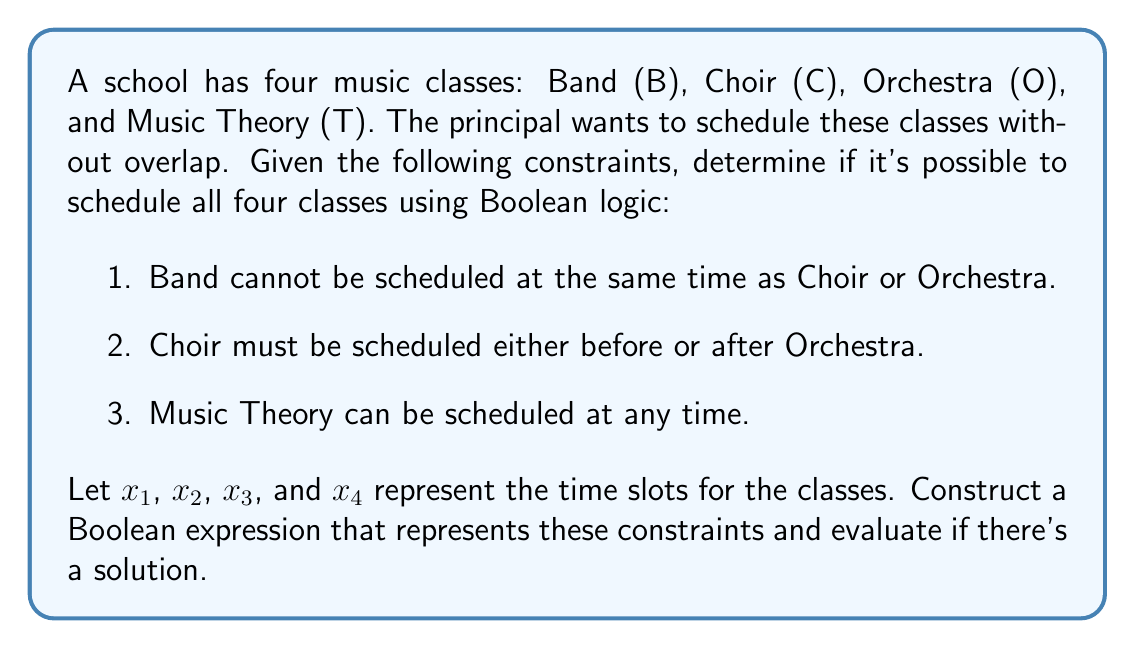Could you help me with this problem? Let's approach this step-by-step:

1) First, we need to represent each constraint as a Boolean expression:

   a) Band cannot be scheduled at the same time as Choir or Orchestra:
      $$(B \neq C) \wedge (B \neq O)$$

   b) Choir must be scheduled either before or after Orchestra:
      $$(C < O) \vee (C > O)$$

   c) Music Theory can be scheduled at any time (no constraint needed)

2) Now, let's assign variables to represent the time slots:
   $$B = x_1, C = x_2, O = x_3, T = x_4$$

3) We can rewrite our constraints using these variables:
   $$(x_1 \neq x_2) \wedge (x_1 \neq x_3) \wedge ((x_2 < x_3) \vee (x_2 > x_3))$$

4) To check if this is satisfiable, we need to find an assignment of values to $x_1$, $x_2$, $x_3$, and $x_4$ that makes the expression true.

5) One possible solution is:
   $$x_1 = 1, x_2 = 2, x_3 = 3, x_4 = 4$$

   This represents scheduling Band first, then Choir, then Orchestra, and finally Music Theory.

6) We can verify this solution:
   $(1 \neq 2) \wedge (1 \neq 3) \wedge ((2 < 3) \vee (2 > 3))$
   $= \text{True} \wedge \text{True} \wedge (\text{True} \vee \text{False})$
   $= \text{True} \wedge \text{True} \wedge \text{True} = \text{True}$

Therefore, it is possible to schedule all four classes without overlap.
Answer: Yes, it's possible. 